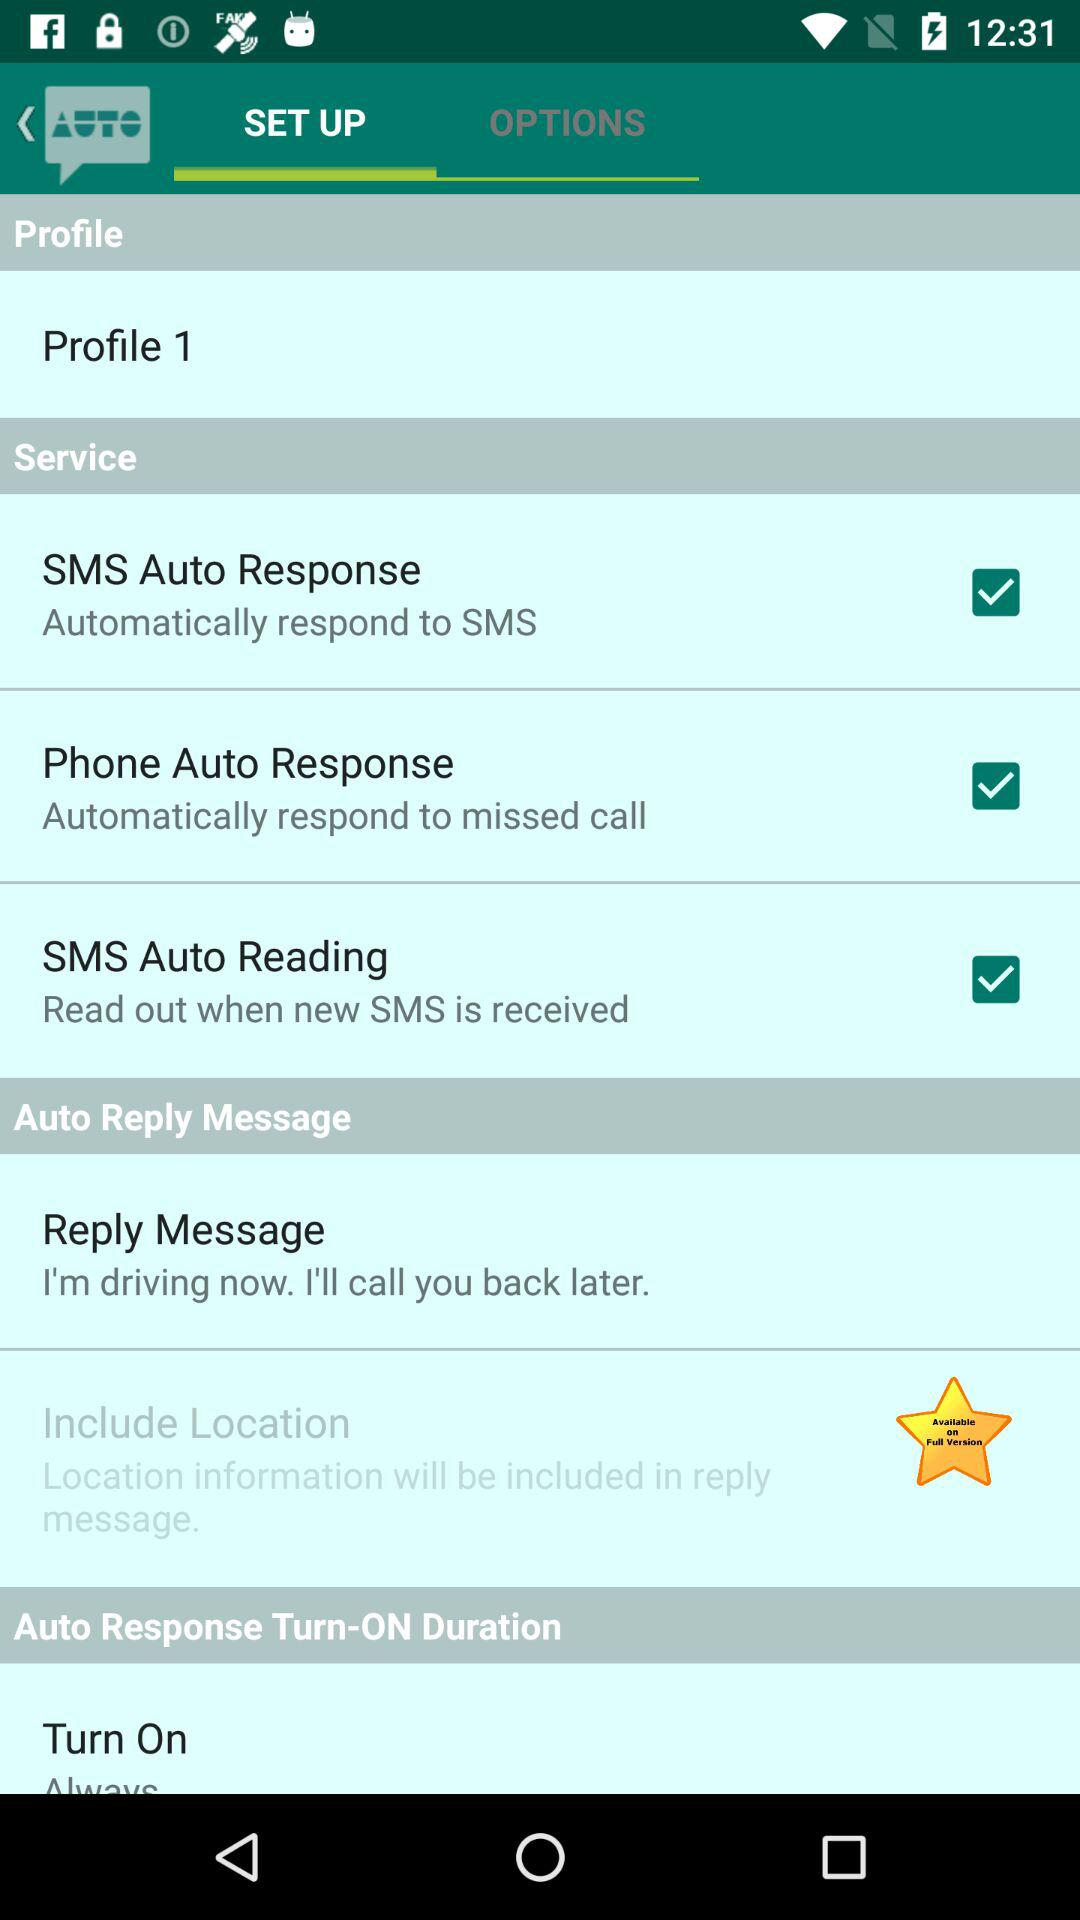What is the status of the "SMS Auto Response" service? The status is "on". 